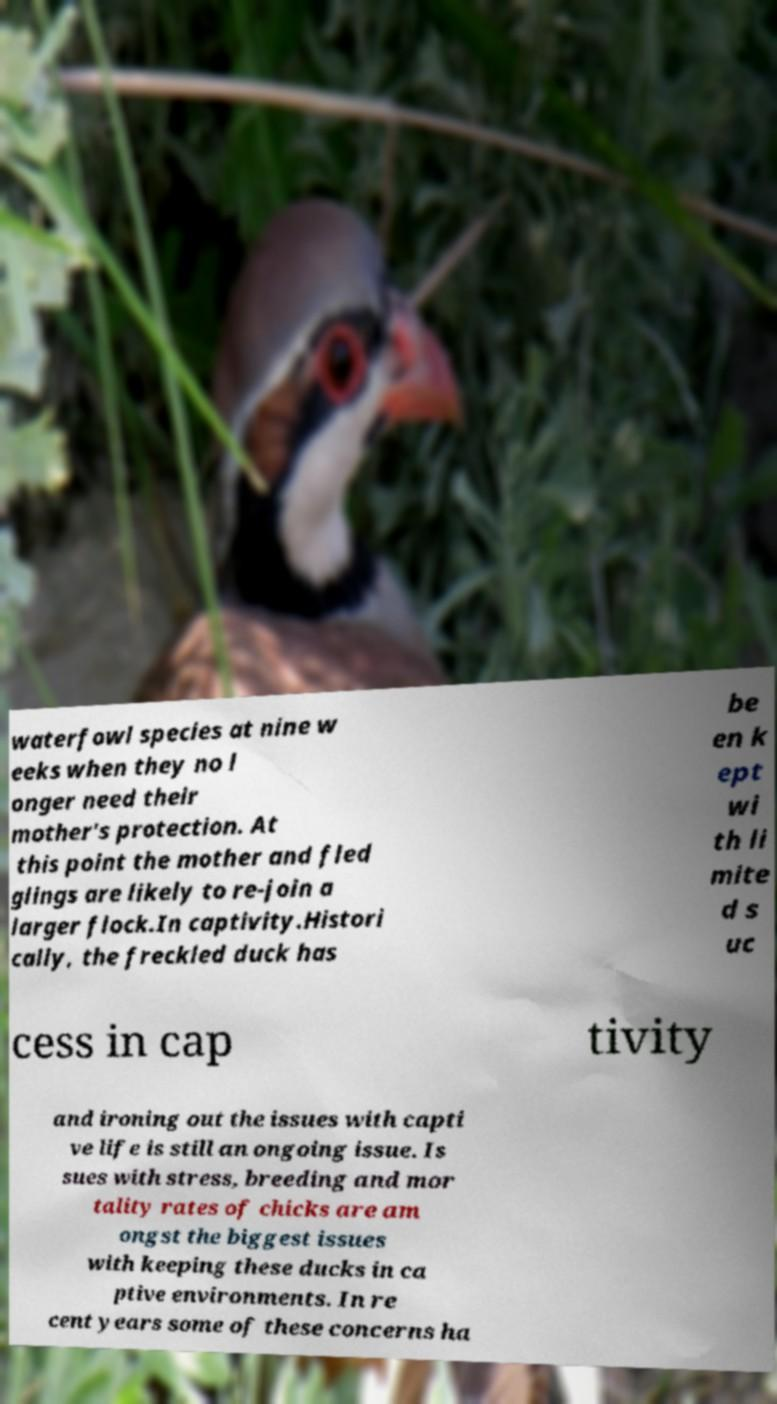Can you accurately transcribe the text from the provided image for me? waterfowl species at nine w eeks when they no l onger need their mother's protection. At this point the mother and fled glings are likely to re-join a larger flock.In captivity.Histori cally, the freckled duck has be en k ept wi th li mite d s uc cess in cap tivity and ironing out the issues with capti ve life is still an ongoing issue. Is sues with stress, breeding and mor tality rates of chicks are am ongst the biggest issues with keeping these ducks in ca ptive environments. In re cent years some of these concerns ha 